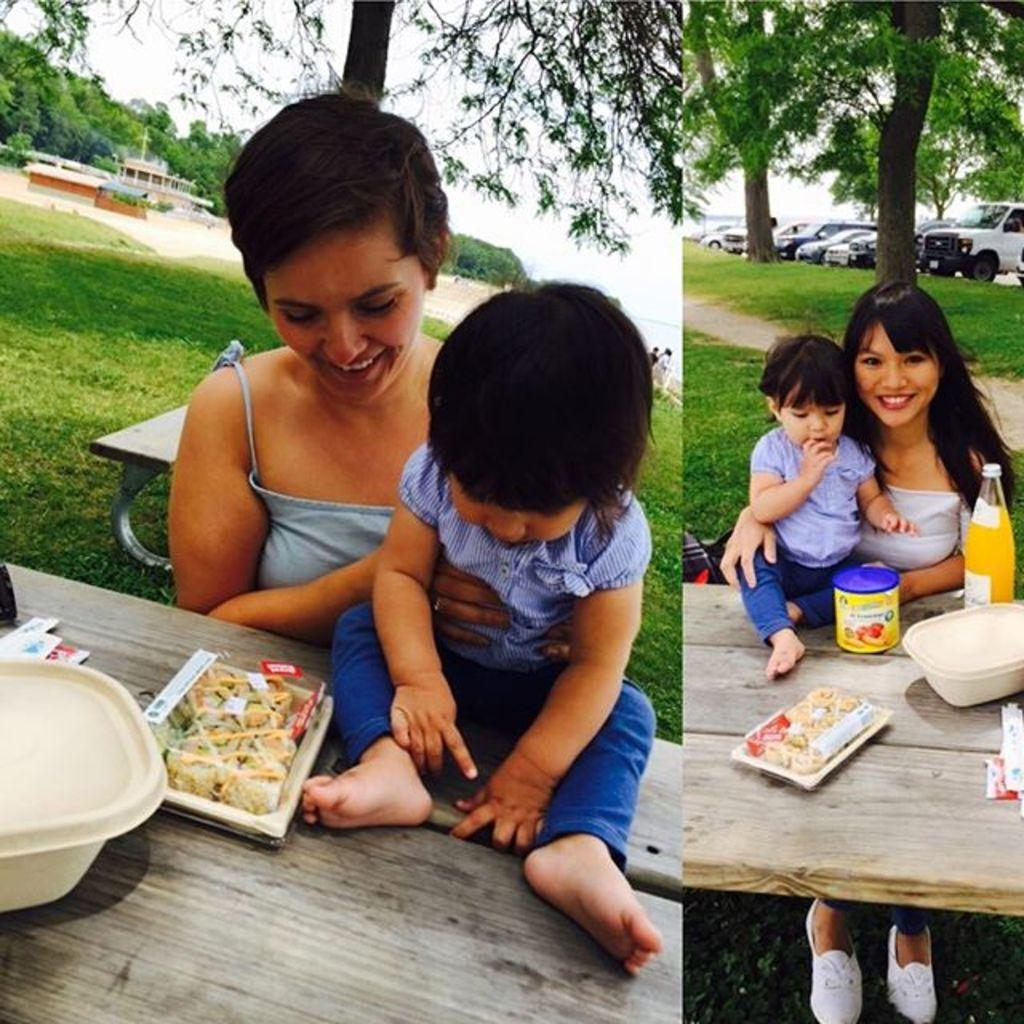What is the woman in the image doing? The woman is sitting on a chair in the image. What is the baby doing in the image? The baby is sitting on a dining table in the image. What is on the dining table? The object on the dining table appears to be food. What is the woman's facial expression? The woman is smiling. What type of vegetation can be seen in the image? There is a tree and grass visible in the image. What type of soup can be smelled in the image? There is no soup present in the image, and therefore no scent can be associated with it. 